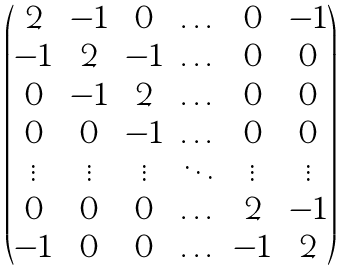Convert formula to latex. <formula><loc_0><loc_0><loc_500><loc_500>\begin{pmatrix} 2 & - 1 & 0 & \dots & 0 & - 1 \\ - 1 & 2 & - 1 & \dots & 0 & 0 \\ 0 & - 1 & 2 & \dots & 0 & 0 \\ 0 & 0 & - 1 & \dots & 0 & 0 \\ \vdots & \vdots & \vdots & \ddots & \vdots & \vdots \\ 0 & 0 & 0 & \dots & 2 & - 1 \\ - 1 & 0 & 0 & \dots & - 1 & 2 \\ \end{pmatrix}</formula> 